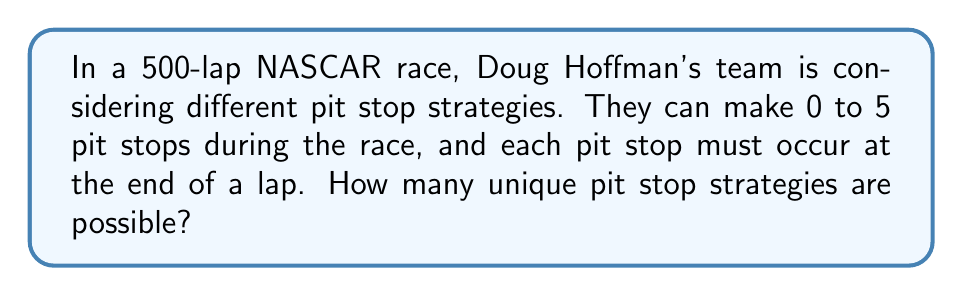Can you solve this math problem? Let's approach this step-by-step:

1) First, we need to recognize that this is a combination problem. We're choosing which laps to make pit stops on from the 500 laps.

2) The number of pit stops can range from 0 to 5. We need to calculate the number of possibilities for each case and sum them up.

3) For each number of pit stops k (where k = 0, 1, 2, 3, 4, or 5), we need to calculate $\binom{500}{k}$.

4) The formula for this combination is:

   $$\binom{500}{k} = \frac{500!}{k!(500-k)!}$$

5) Let's calculate each case:

   For 0 pit stops: $\binom{500}{0} = 1$
   For 1 pit stop:  $\binom{500}{1} = 500$
   For 2 pit stops: $\binom{500}{2} = 124,750$
   For 3 pit stops: $\binom{500}{3} = 20,708,500$
   For 4 pit stops: $\binom{500}{4} = 2,573,031,125$
   For 5 pit stops: $\binom{500}{5} = 255,244,687,600$

6) The total number of unique strategies is the sum of all these values:

   $$1 + 500 + 124,750 + 20,708,500 + 2,573,031,125 + 255,244,687,600 = 257,838,551,976$$

Therefore, there are 257,838,551,976 unique pit stop strategies possible.
Answer: 257,838,551,976 